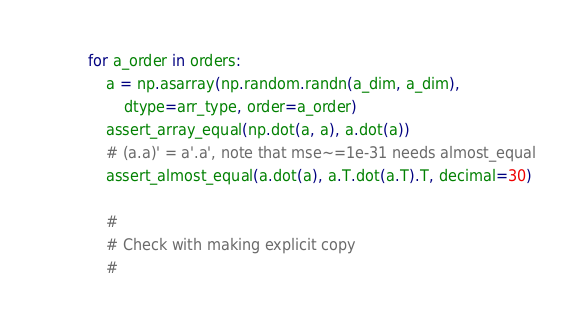Convert code to text. <code><loc_0><loc_0><loc_500><loc_500><_Python_>        for a_order in orders:
            a = np.asarray(np.random.randn(a_dim, a_dim),
                dtype=arr_type, order=a_order)
            assert_array_equal(np.dot(a, a), a.dot(a))
            # (a.a)' = a'.a', note that mse~=1e-31 needs almost_equal
            assert_almost_equal(a.dot(a), a.T.dot(a.T).T, decimal=30)

            #
            # Check with making explicit copy
            #</code> 